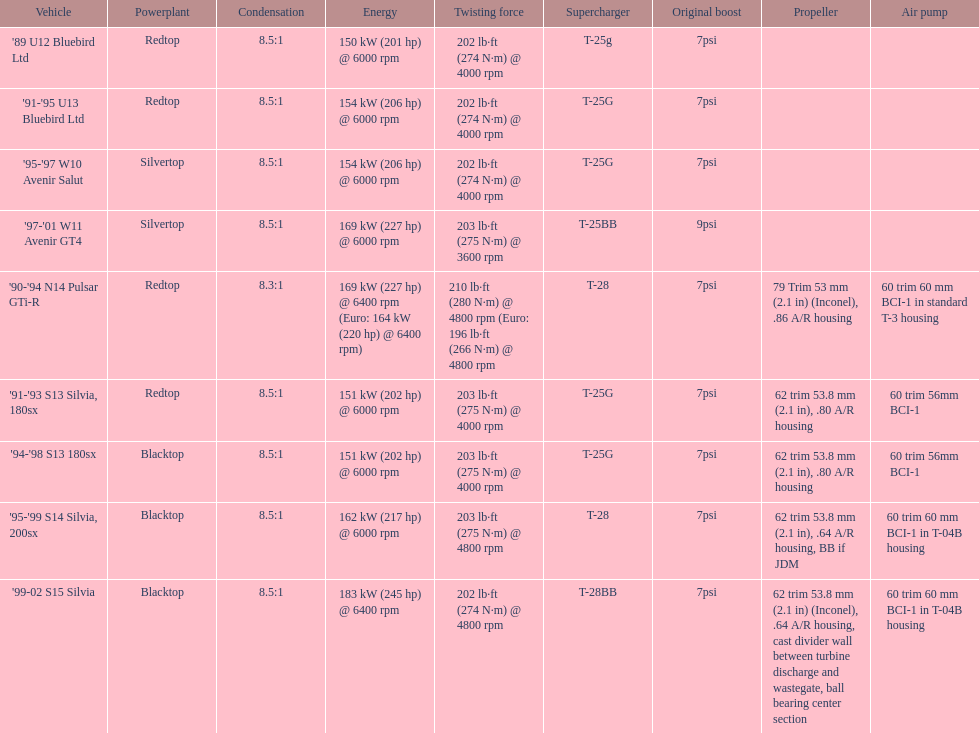Which engine(s) has the least amount of power? Redtop. 